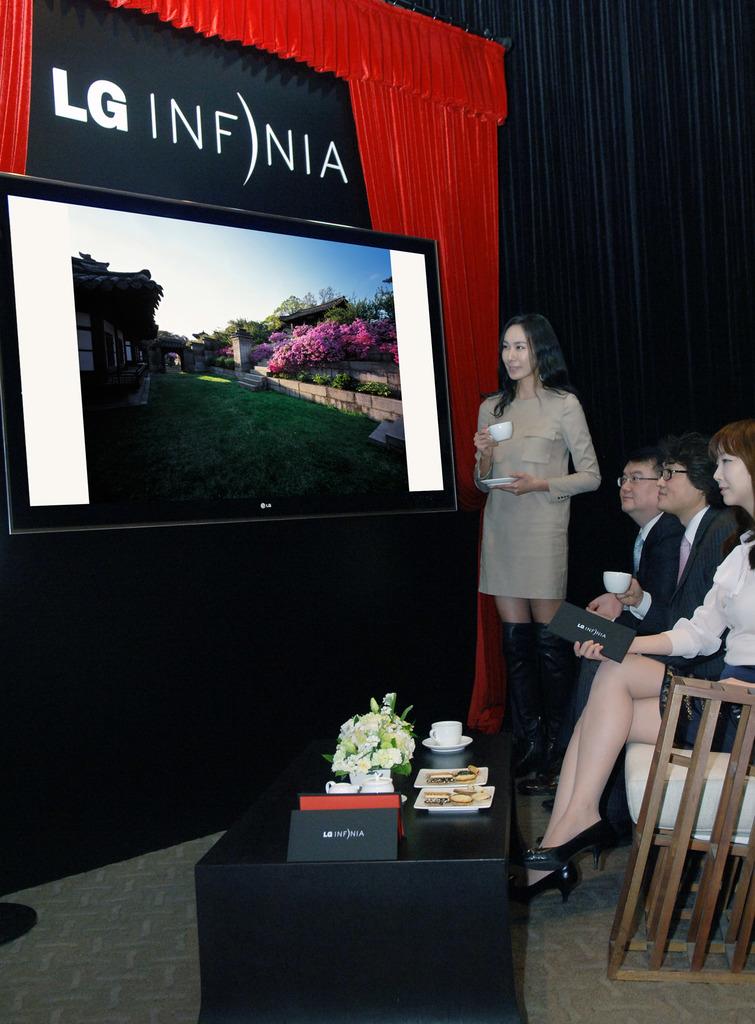What brand of tv is being showcased here?
Offer a very short reply. Lg. What brand is written in white letters/?
Make the answer very short. Lg. 